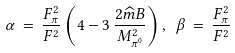<formula> <loc_0><loc_0><loc_500><loc_500>\alpha \, = \, \frac { F _ { \pi } ^ { 2 } } { F ^ { 2 } } \left ( 4 - 3 \, \frac { 2 { \widehat { m } } B } { M _ { \pi ^ { 0 } } ^ { 2 } } \right ) , \ \beta \, = \, \frac { F _ { \pi } ^ { 2 } } { F ^ { 2 } }</formula> 